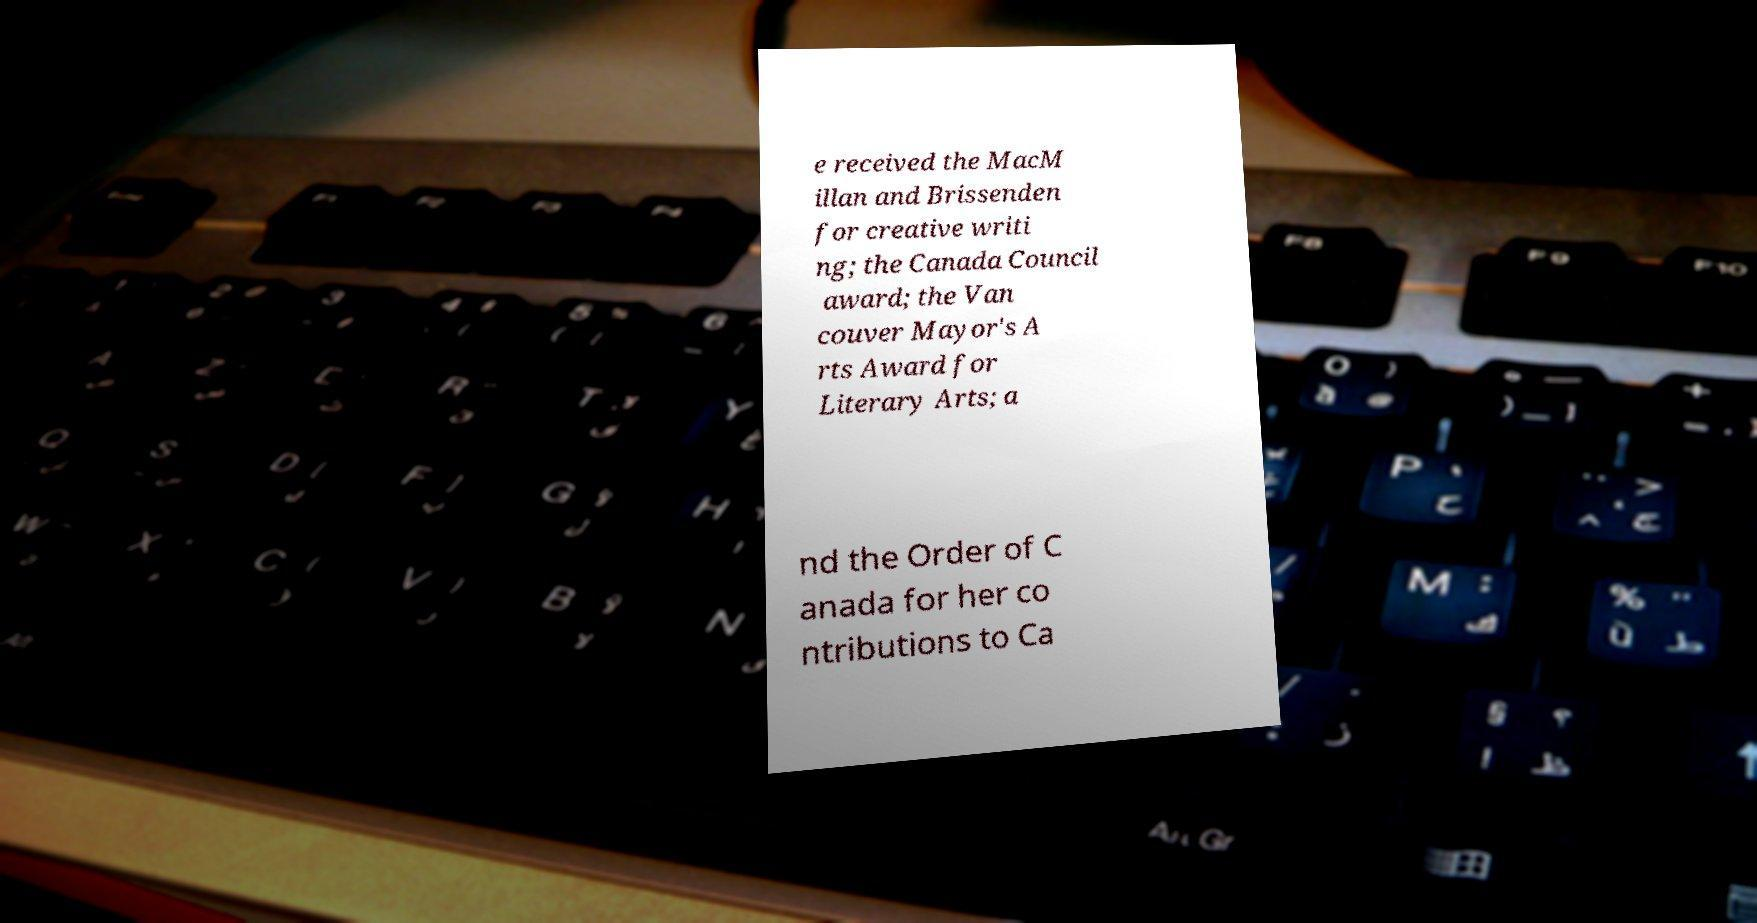Can you read and provide the text displayed in the image?This photo seems to have some interesting text. Can you extract and type it out for me? e received the MacM illan and Brissenden for creative writi ng; the Canada Council award; the Van couver Mayor's A rts Award for Literary Arts; a nd the Order of C anada for her co ntributions to Ca 